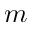<formula> <loc_0><loc_0><loc_500><loc_500>m</formula> 